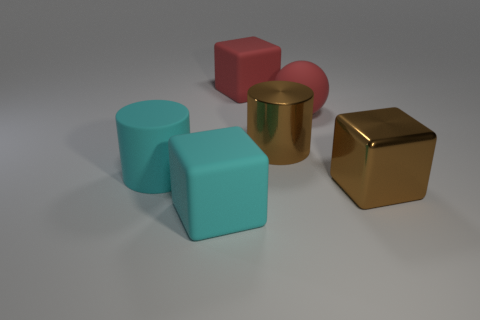Is there a big matte thing that has the same color as the rubber cylinder?
Give a very brief answer. Yes. What color is the large matte object that is behind the red matte thing that is in front of the big cube that is behind the large red matte sphere?
Your answer should be compact. Red. Are the brown cylinder and the sphere in front of the red block made of the same material?
Keep it short and to the point. No. What material is the big brown cylinder?
Provide a short and direct response. Metal. What is the material of the cylinder that is the same color as the metal block?
Offer a very short reply. Metal. How many other things are the same material as the cyan cylinder?
Give a very brief answer. 3. What is the shape of the thing that is both in front of the cyan cylinder and left of the sphere?
Offer a terse response. Cube. There is a big cylinder that is the same material as the big red ball; what color is it?
Offer a terse response. Cyan. Are there the same number of large objects left of the large brown metal cube and metal cylinders?
Ensure brevity in your answer.  No. There is a brown thing that is the same size as the brown cube; what is its shape?
Offer a very short reply. Cylinder. 